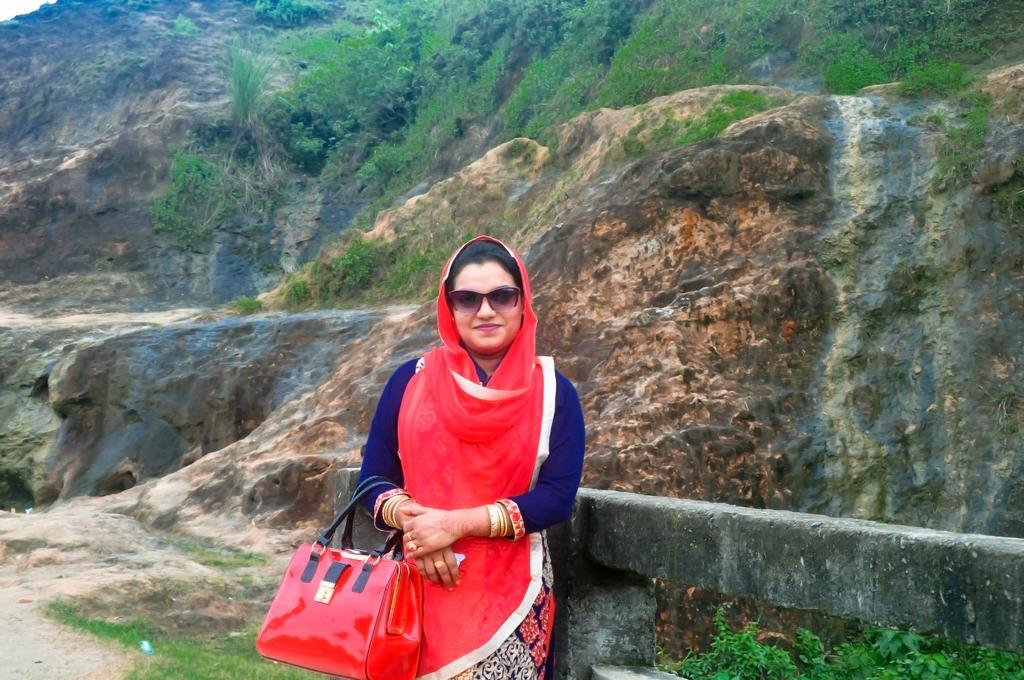What is the main subject of the image? The main subject of the image is a woman. What is the woman doing in the image? The woman is standing and smiling in the image. What is the woman holding in the image? The woman is holding a red handbag in the image. What is the woman wearing in the image? The woman is wearing a red dupatta with a blue dress and goggles in the image. What can be seen in the background of the image? There are small plants in the background of the image, and it appears to be on a hill. What type of pancake can be seen in the image? There is no pancake present in the image. What noise can be heard coming from the woman in the image? The image is a still photograph, so no noise can be heard from the woman in the image. 